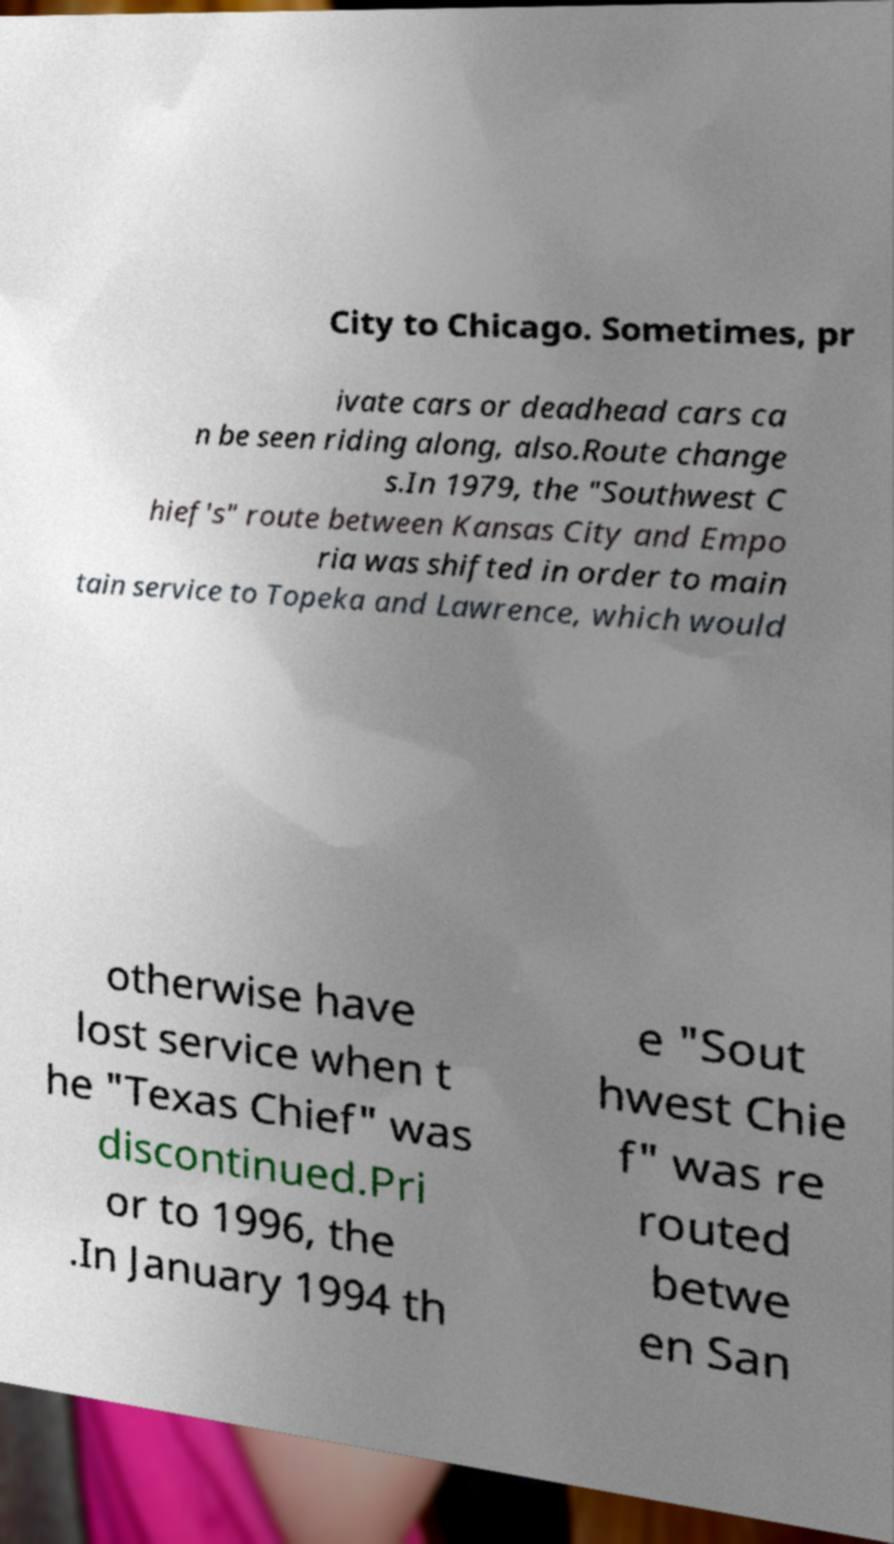Could you assist in decoding the text presented in this image and type it out clearly? City to Chicago. Sometimes, pr ivate cars or deadhead cars ca n be seen riding along, also.Route change s.In 1979, the "Southwest C hief's" route between Kansas City and Empo ria was shifted in order to main tain service to Topeka and Lawrence, which would otherwise have lost service when t he "Texas Chief" was discontinued.Pri or to 1996, the .In January 1994 th e "Sout hwest Chie f" was re routed betwe en San 